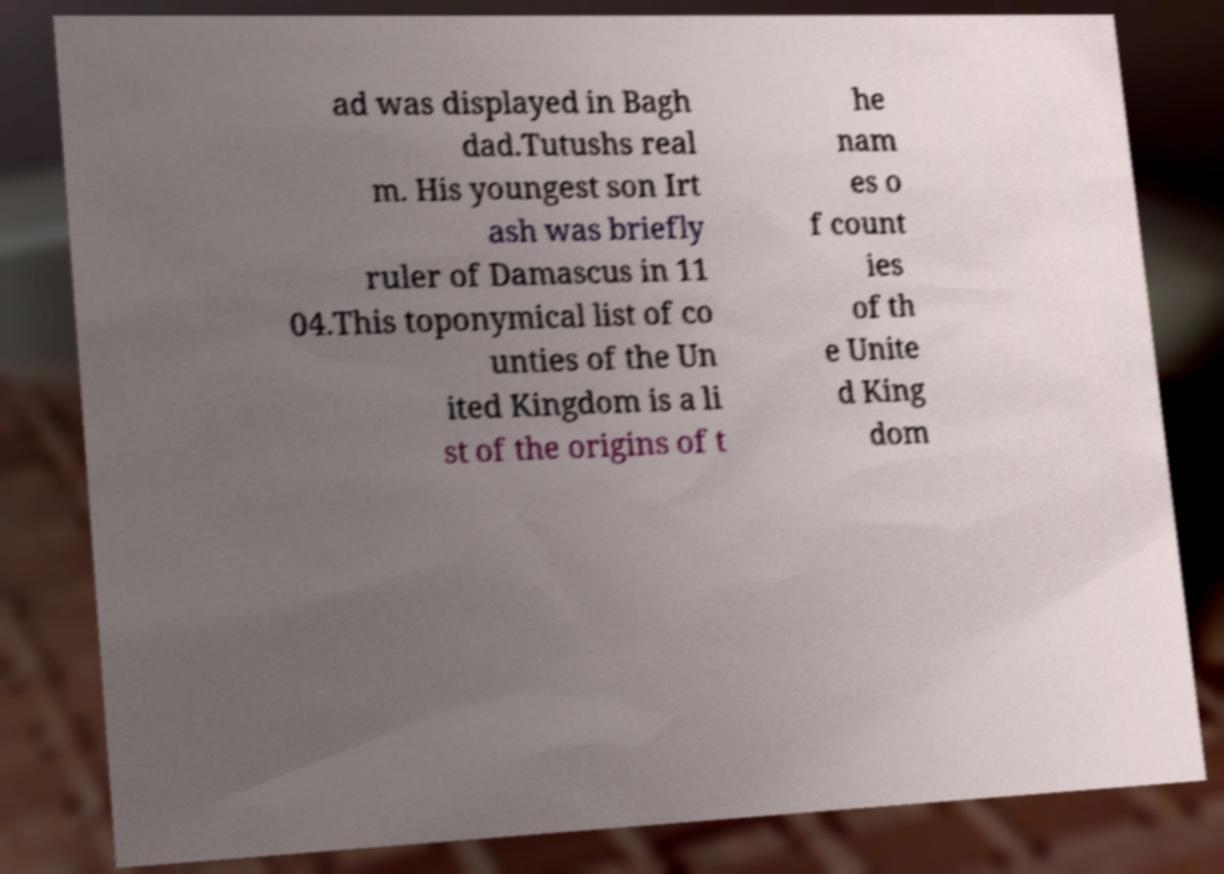Could you assist in decoding the text presented in this image and type it out clearly? ad was displayed in Bagh dad.Tutushs real m. His youngest son Irt ash was briefly ruler of Damascus in 11 04.This toponymical list of co unties of the Un ited Kingdom is a li st of the origins of t he nam es o f count ies of th e Unite d King dom 